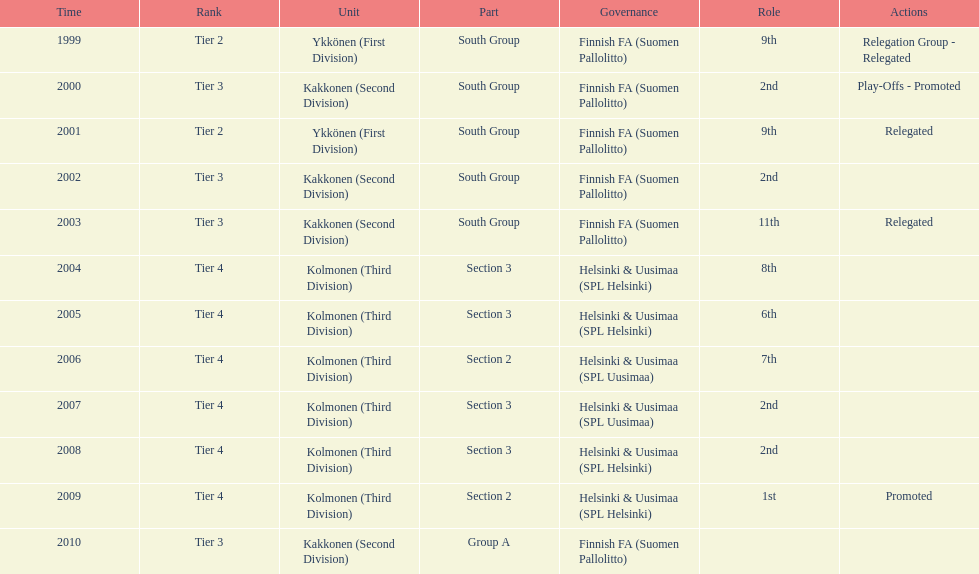How many 2nd positions were there? 4. 